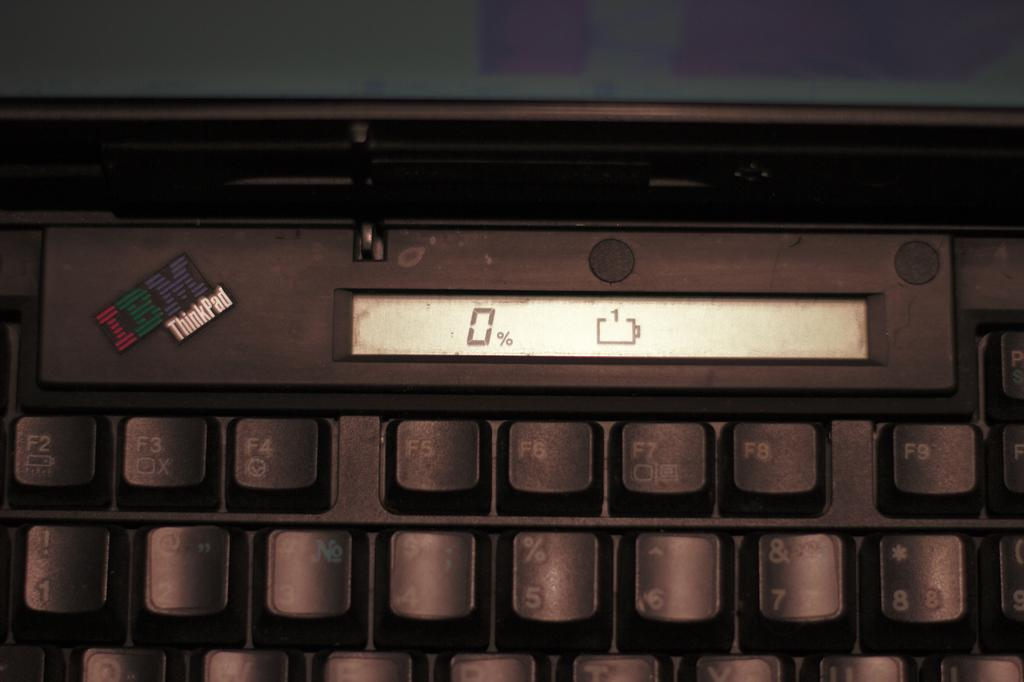<image>
Share a concise interpretation of the image provided. A laptop computer that says IBM ThinkPad is showing 0% battery power. 